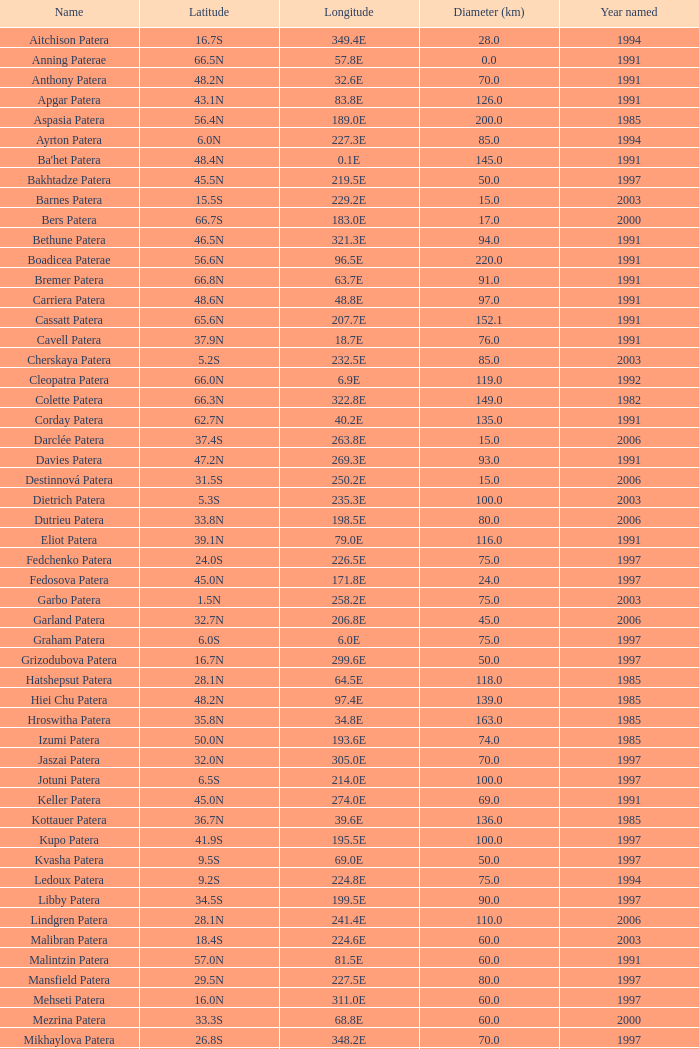What does the longitude of raskova paterae represent? 222.8E. 